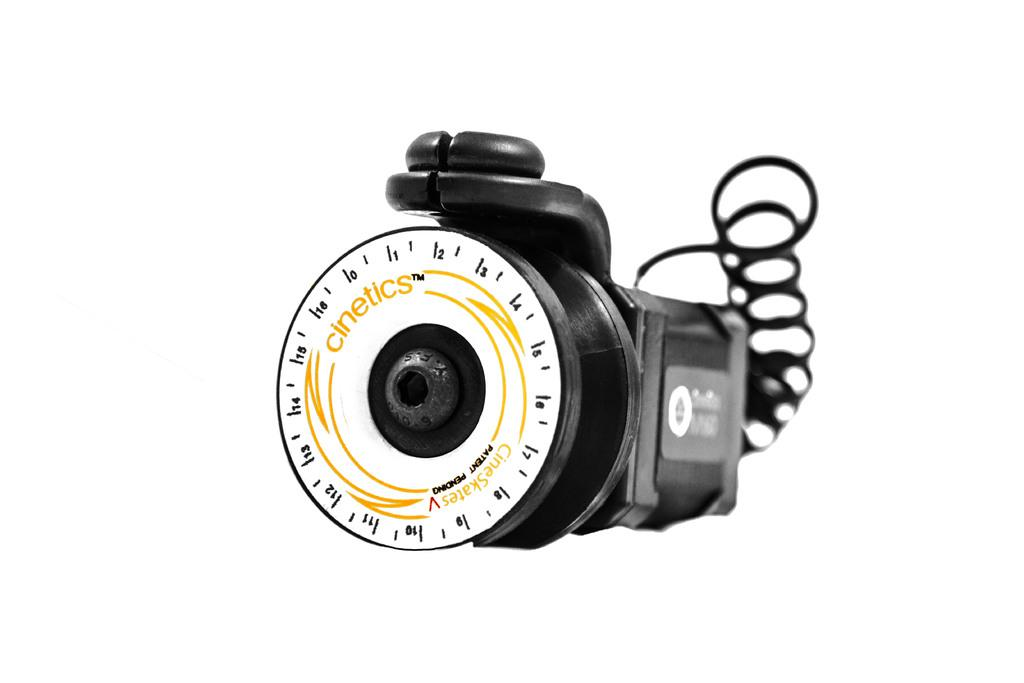What type of camera is visible in the image? There is a film camera in the image. Is there anything connected to the film camera? Yes, there is a spiral cable connected to the film camera. Can you see a snail crawling on the film camera in the image? No, there is no snail present in the image. What type of receipt is visible in the image? There is no receipt present in the image. 